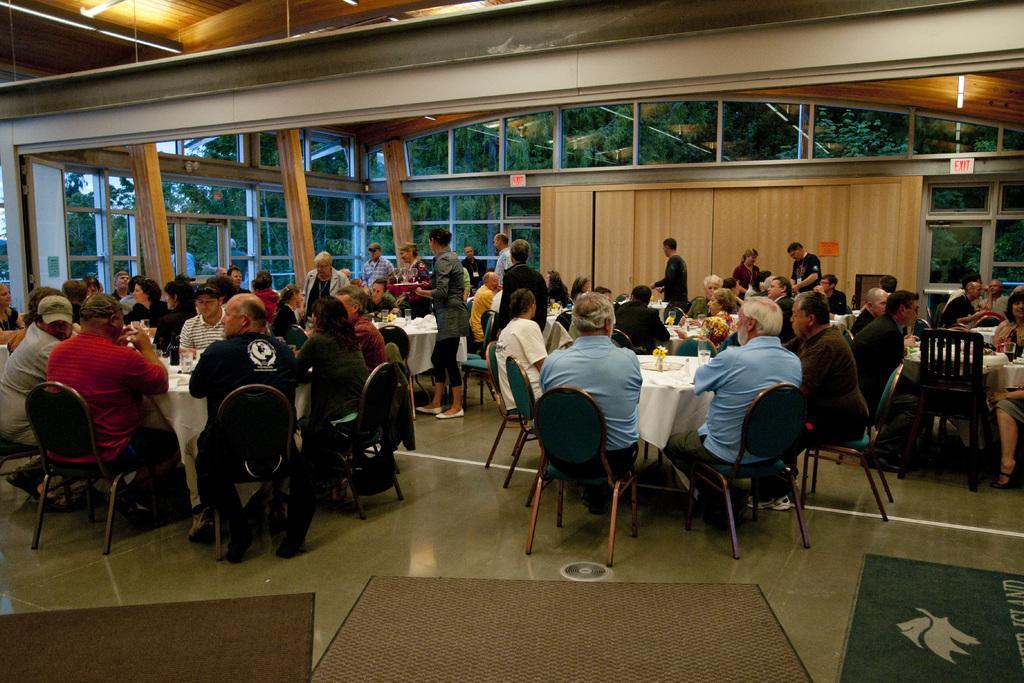In one or two sentences, can you explain what this image depicts? This picture shows a group of people seated in a room and we see few people standing and we see tables 